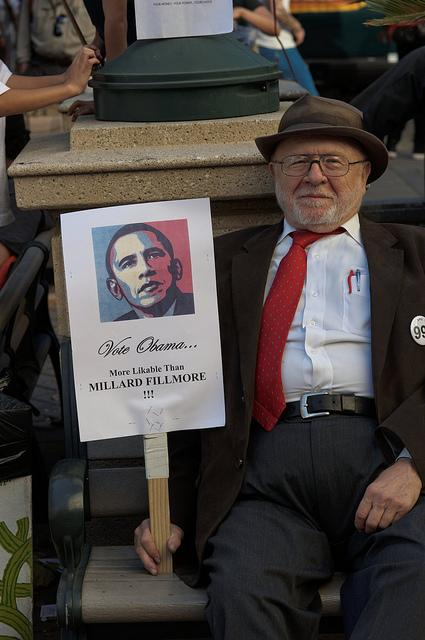Under what circumstance might children wear the red item the man is wearing? halloween 